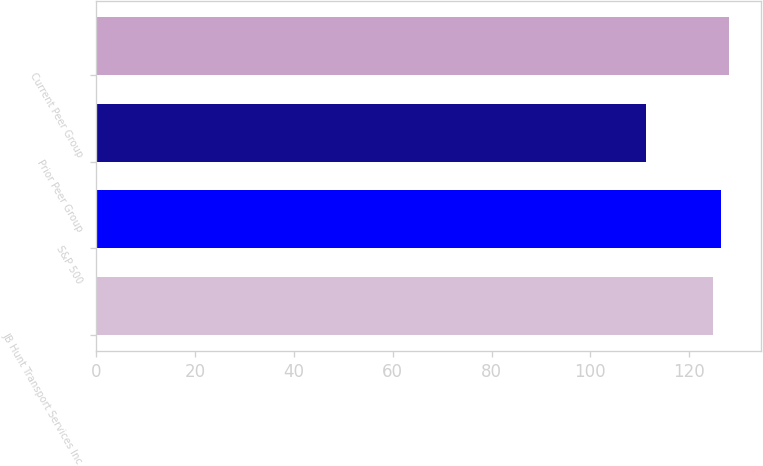Convert chart to OTSL. <chart><loc_0><loc_0><loc_500><loc_500><bar_chart><fcel>JB Hunt Transport Services Inc<fcel>S&P 500<fcel>Prior Peer Group<fcel>Current Peer Group<nl><fcel>124.85<fcel>126.46<fcel>111.2<fcel>128.04<nl></chart> 